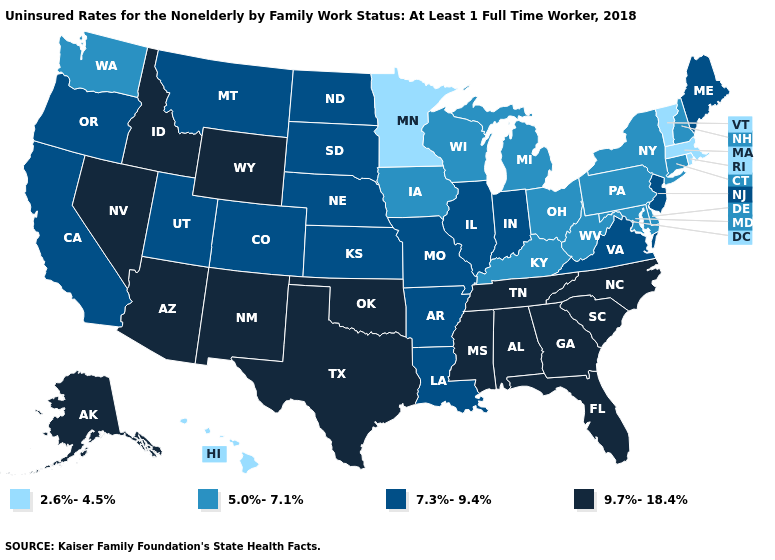What is the lowest value in the Northeast?
Be succinct. 2.6%-4.5%. Does West Virginia have the highest value in the South?
Give a very brief answer. No. What is the value of Wisconsin?
Keep it brief. 5.0%-7.1%. Which states hav the highest value in the South?
Answer briefly. Alabama, Florida, Georgia, Mississippi, North Carolina, Oklahoma, South Carolina, Tennessee, Texas. Is the legend a continuous bar?
Write a very short answer. No. Does Texas have a higher value than Florida?
Write a very short answer. No. Name the states that have a value in the range 5.0%-7.1%?
Concise answer only. Connecticut, Delaware, Iowa, Kentucky, Maryland, Michigan, New Hampshire, New York, Ohio, Pennsylvania, Washington, West Virginia, Wisconsin. Does Mississippi have a higher value than Oklahoma?
Short answer required. No. What is the value of Iowa?
Be succinct. 5.0%-7.1%. What is the value of Ohio?
Concise answer only. 5.0%-7.1%. Name the states that have a value in the range 9.7%-18.4%?
Write a very short answer. Alabama, Alaska, Arizona, Florida, Georgia, Idaho, Mississippi, Nevada, New Mexico, North Carolina, Oklahoma, South Carolina, Tennessee, Texas, Wyoming. What is the value of Nebraska?
Short answer required. 7.3%-9.4%. Among the states that border Utah , does Colorado have the lowest value?
Write a very short answer. Yes. What is the highest value in the South ?
Quick response, please. 9.7%-18.4%. 